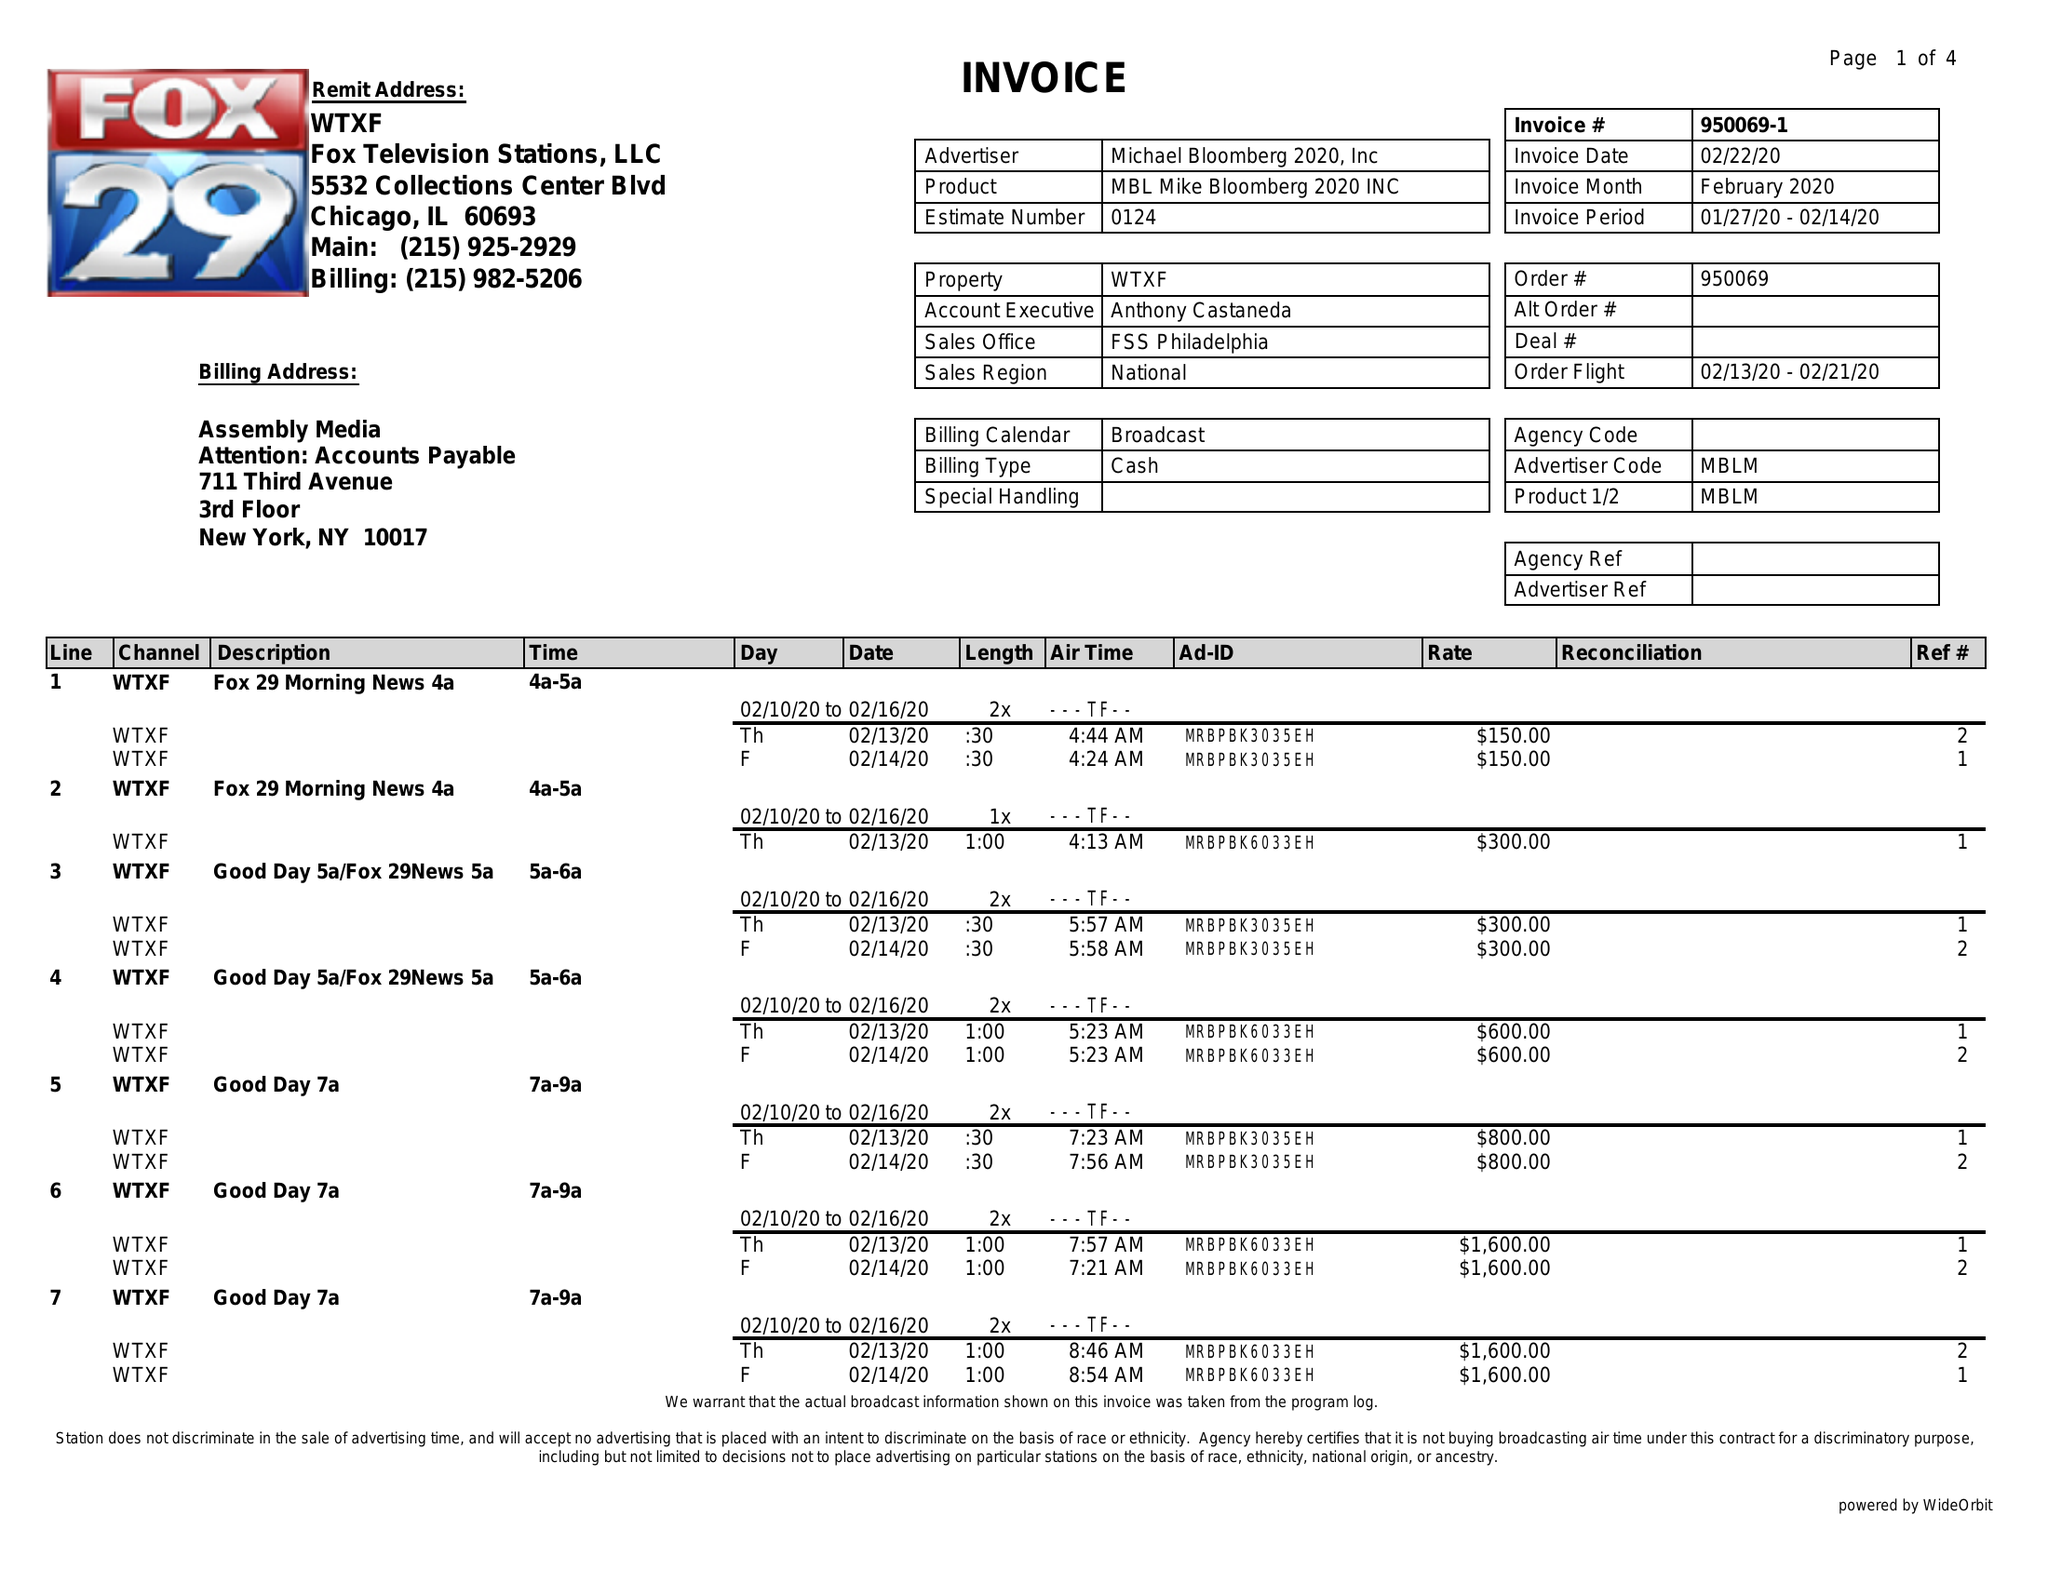What is the value for the gross_amount?
Answer the question using a single word or phrase. 29800.00 